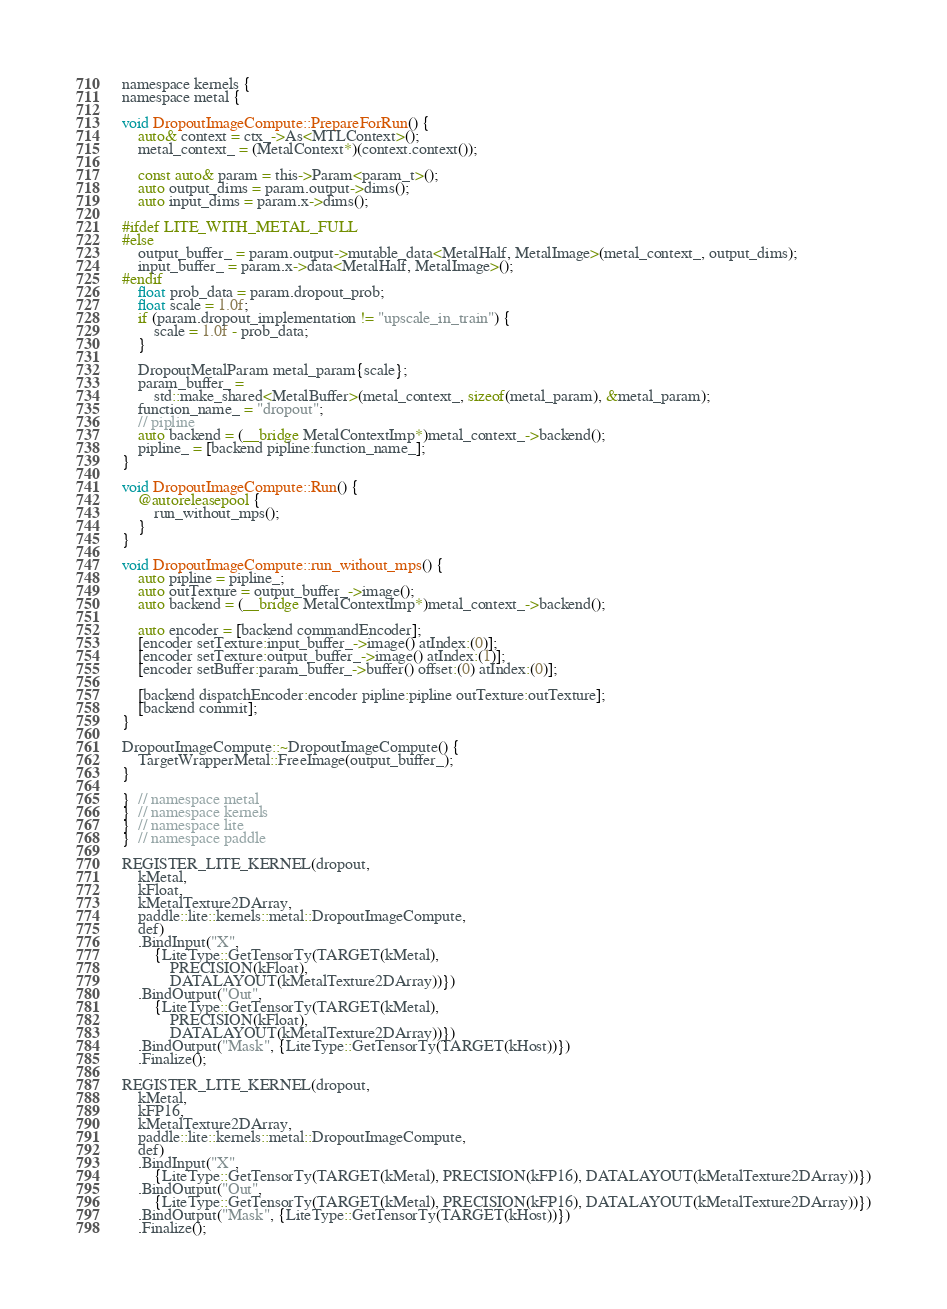Convert code to text. <code><loc_0><loc_0><loc_500><loc_500><_ObjectiveC_>namespace kernels {
namespace metal {

void DropoutImageCompute::PrepareForRun() {
    auto& context = ctx_->As<MTLContext>();
    metal_context_ = (MetalContext*)(context.context());

    const auto& param = this->Param<param_t>();
    auto output_dims = param.output->dims();
    auto input_dims = param.x->dims();

#ifdef LITE_WITH_METAL_FULL
#else
    output_buffer_ = param.output->mutable_data<MetalHalf, MetalImage>(metal_context_, output_dims);
    input_buffer_ = param.x->data<MetalHalf, MetalImage>();
#endif
    float prob_data = param.dropout_prob;
    float scale = 1.0f;
    if (param.dropout_implementation != "upscale_in_train") {
        scale = 1.0f - prob_data;
    }

    DropoutMetalParam metal_param{scale};
    param_buffer_ =
        std::make_shared<MetalBuffer>(metal_context_, sizeof(metal_param), &metal_param);
    function_name_ = "dropout";
    // pipline
    auto backend = (__bridge MetalContextImp*)metal_context_->backend();
    pipline_ = [backend pipline:function_name_];
}

void DropoutImageCompute::Run() {
    @autoreleasepool {
        run_without_mps();
    }
}

void DropoutImageCompute::run_without_mps() {
    auto pipline = pipline_;
    auto outTexture = output_buffer_->image();
    auto backend = (__bridge MetalContextImp*)metal_context_->backend();

    auto encoder = [backend commandEncoder];
    [encoder setTexture:input_buffer_->image() atIndex:(0)];
    [encoder setTexture:output_buffer_->image() atIndex:(1)];
    [encoder setBuffer:param_buffer_->buffer() offset:(0) atIndex:(0)];

    [backend dispatchEncoder:encoder pipline:pipline outTexture:outTexture];
    [backend commit];
}

DropoutImageCompute::~DropoutImageCompute() {
    TargetWrapperMetal::FreeImage(output_buffer_);
}

}  // namespace metal
}  // namespace kernels
}  // namespace lite
}  // namespace paddle

REGISTER_LITE_KERNEL(dropout,
    kMetal,
    kFloat,
    kMetalTexture2DArray,
    paddle::lite::kernels::metal::DropoutImageCompute,
    def)
    .BindInput("X",
        {LiteType::GetTensorTy(TARGET(kMetal),
            PRECISION(kFloat),
            DATALAYOUT(kMetalTexture2DArray))})
    .BindOutput("Out",
        {LiteType::GetTensorTy(TARGET(kMetal),
            PRECISION(kFloat),
            DATALAYOUT(kMetalTexture2DArray))})
    .BindOutput("Mask", {LiteType::GetTensorTy(TARGET(kHost))})
    .Finalize();

REGISTER_LITE_KERNEL(dropout,
    kMetal,
    kFP16,
    kMetalTexture2DArray,
    paddle::lite::kernels::metal::DropoutImageCompute,
    def)
    .BindInput("X",
        {LiteType::GetTensorTy(TARGET(kMetal), PRECISION(kFP16), DATALAYOUT(kMetalTexture2DArray))})
    .BindOutput("Out",
        {LiteType::GetTensorTy(TARGET(kMetal), PRECISION(kFP16), DATALAYOUT(kMetalTexture2DArray))})
    .BindOutput("Mask", {LiteType::GetTensorTy(TARGET(kHost))})
    .Finalize();
</code> 